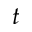<formula> <loc_0><loc_0><loc_500><loc_500>t</formula> 